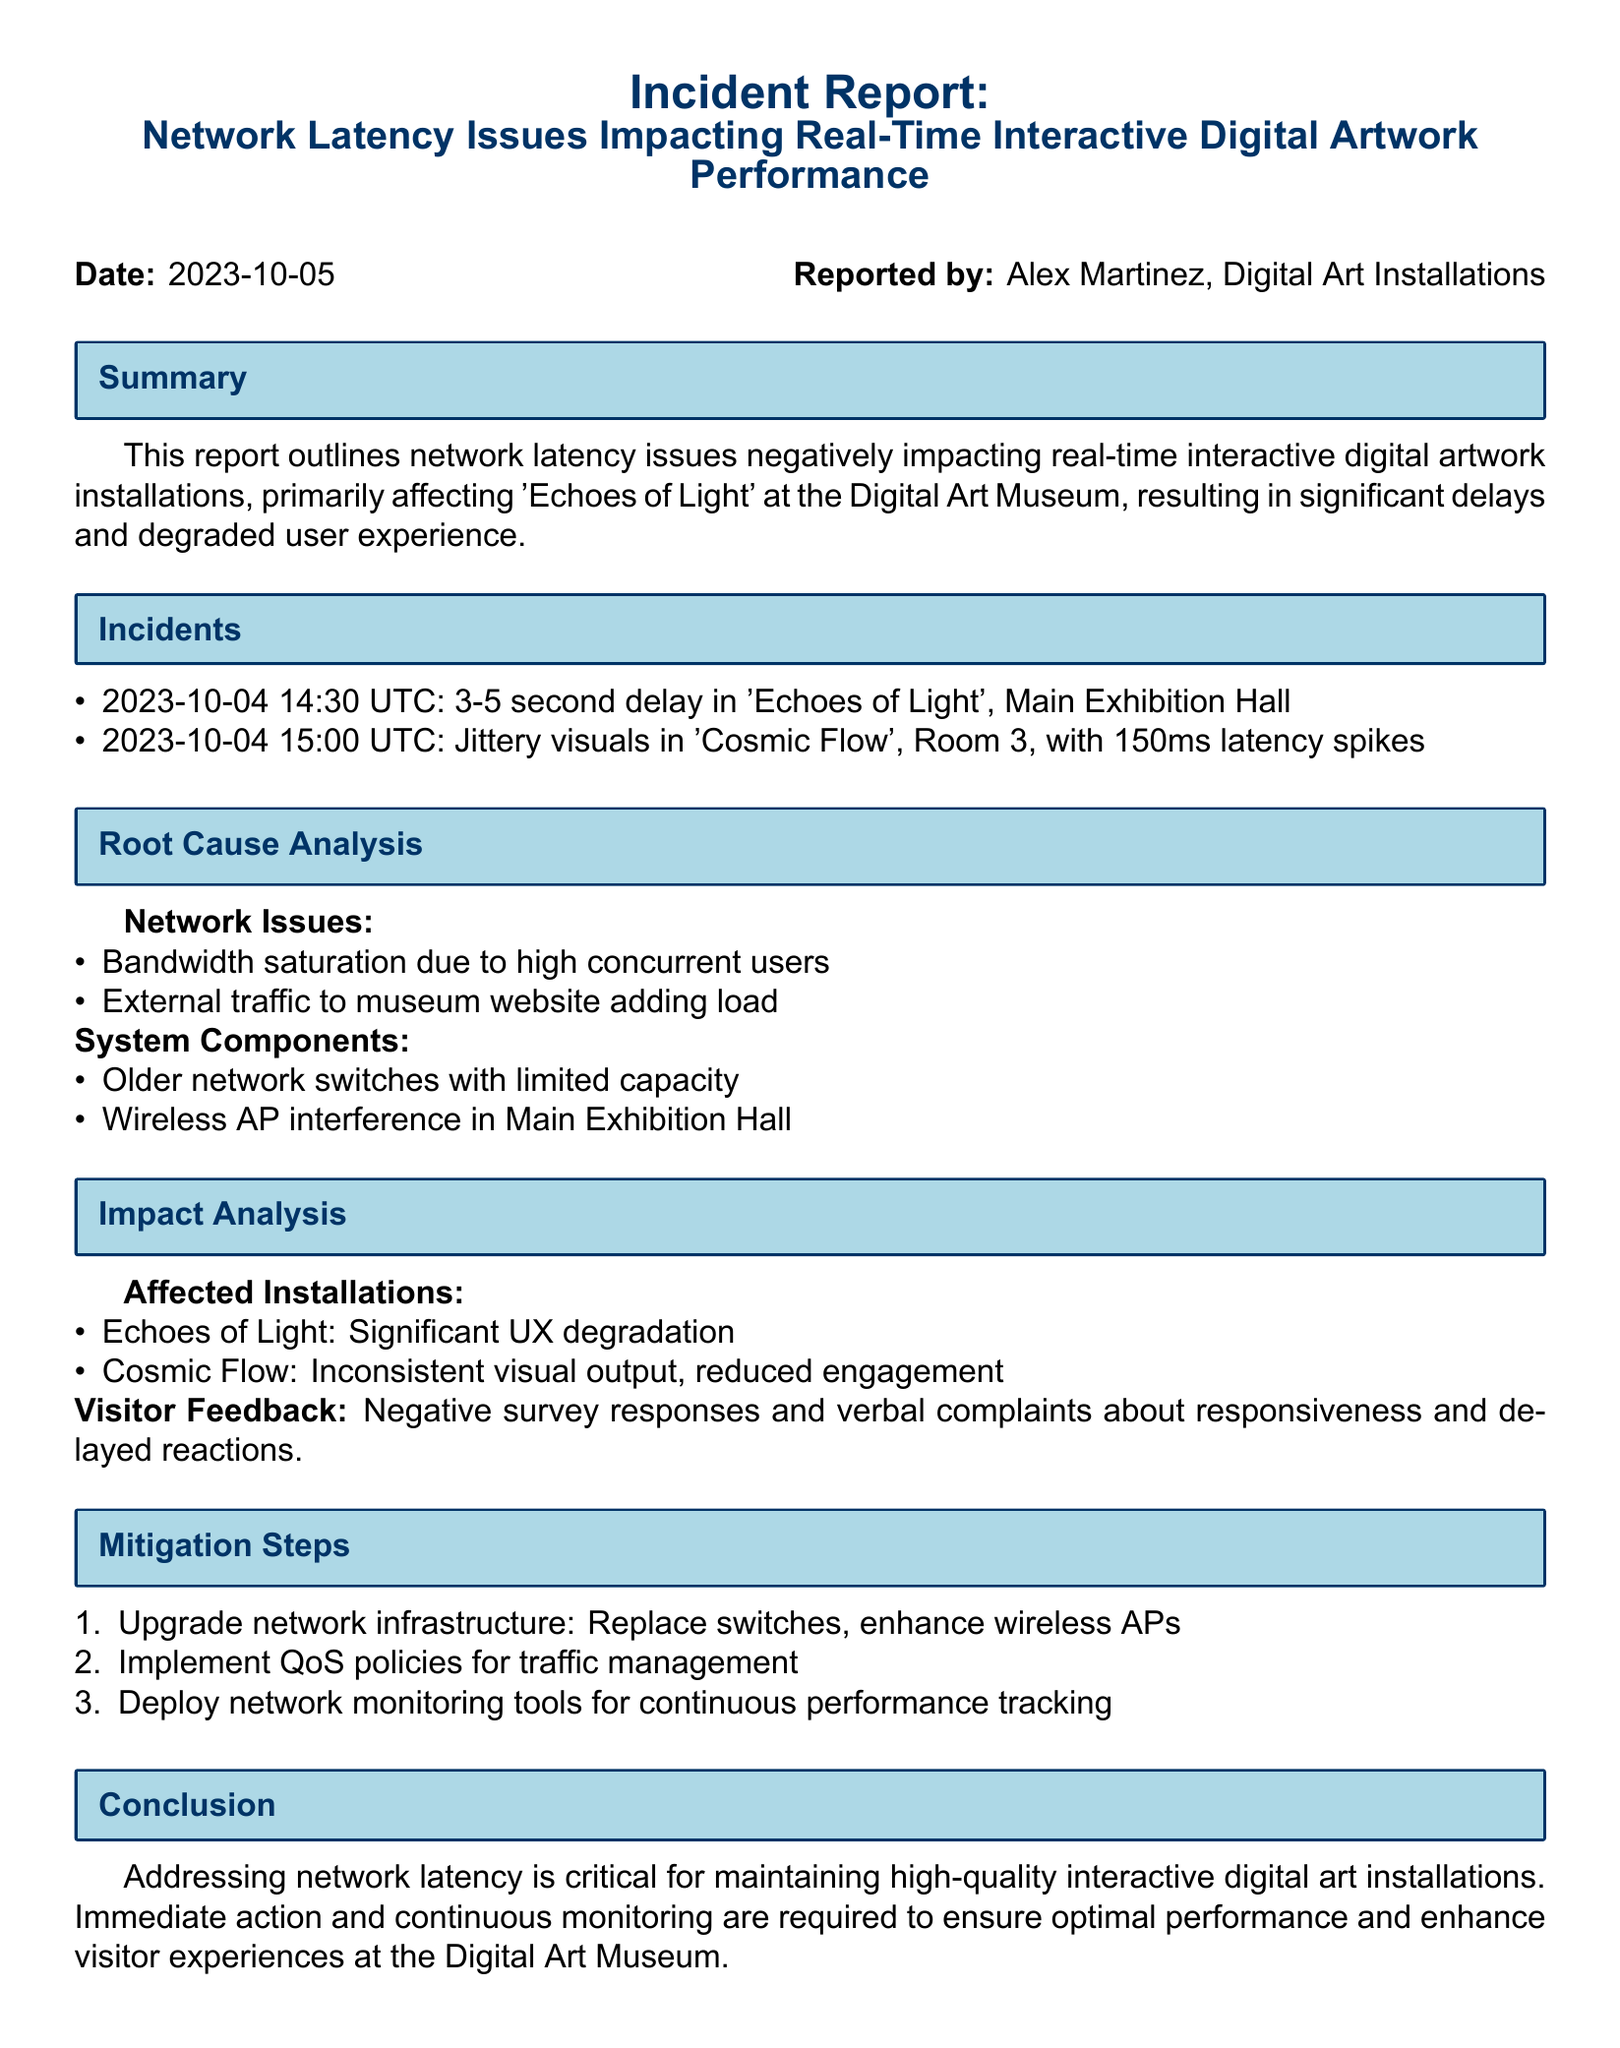What is the date of the incident report? The date is mentioned in the header of the report.
Answer: 2023-10-05 Who reported the incident? The name of the person who reported the incident is provided at the top of the document.
Answer: Alex Martinez What installation was primarily affected by the latency issues? The report specifies which digital artwork installation faced the most issues.
Answer: Echoes of Light What type of network issues were identified? The report outlines specific network issues causing the problems.
Answer: Bandwidth saturation What was the latency spike duration observed in 'Cosmic Flow'? The document lists the specifics of the latency spikes for this installation.
Answer: 150ms How many incidents were reported on 2023-10-04? The report includes specific instances of incidents occurring on that date.
Answer: 2 What mitigation step involves replacing hardware? The proposed solutions detail the need for hardware enhancements.
Answer: Upgrade network infrastructure What kind of visitor feedback was received? The report summarizes the feedback from visitors regarding their experience.
Answer: Negative survey responses What was the time and date of the first reported incident? The report provides the timing of incidents in a list format.
Answer: 2023-10-04 14:30 UTC 